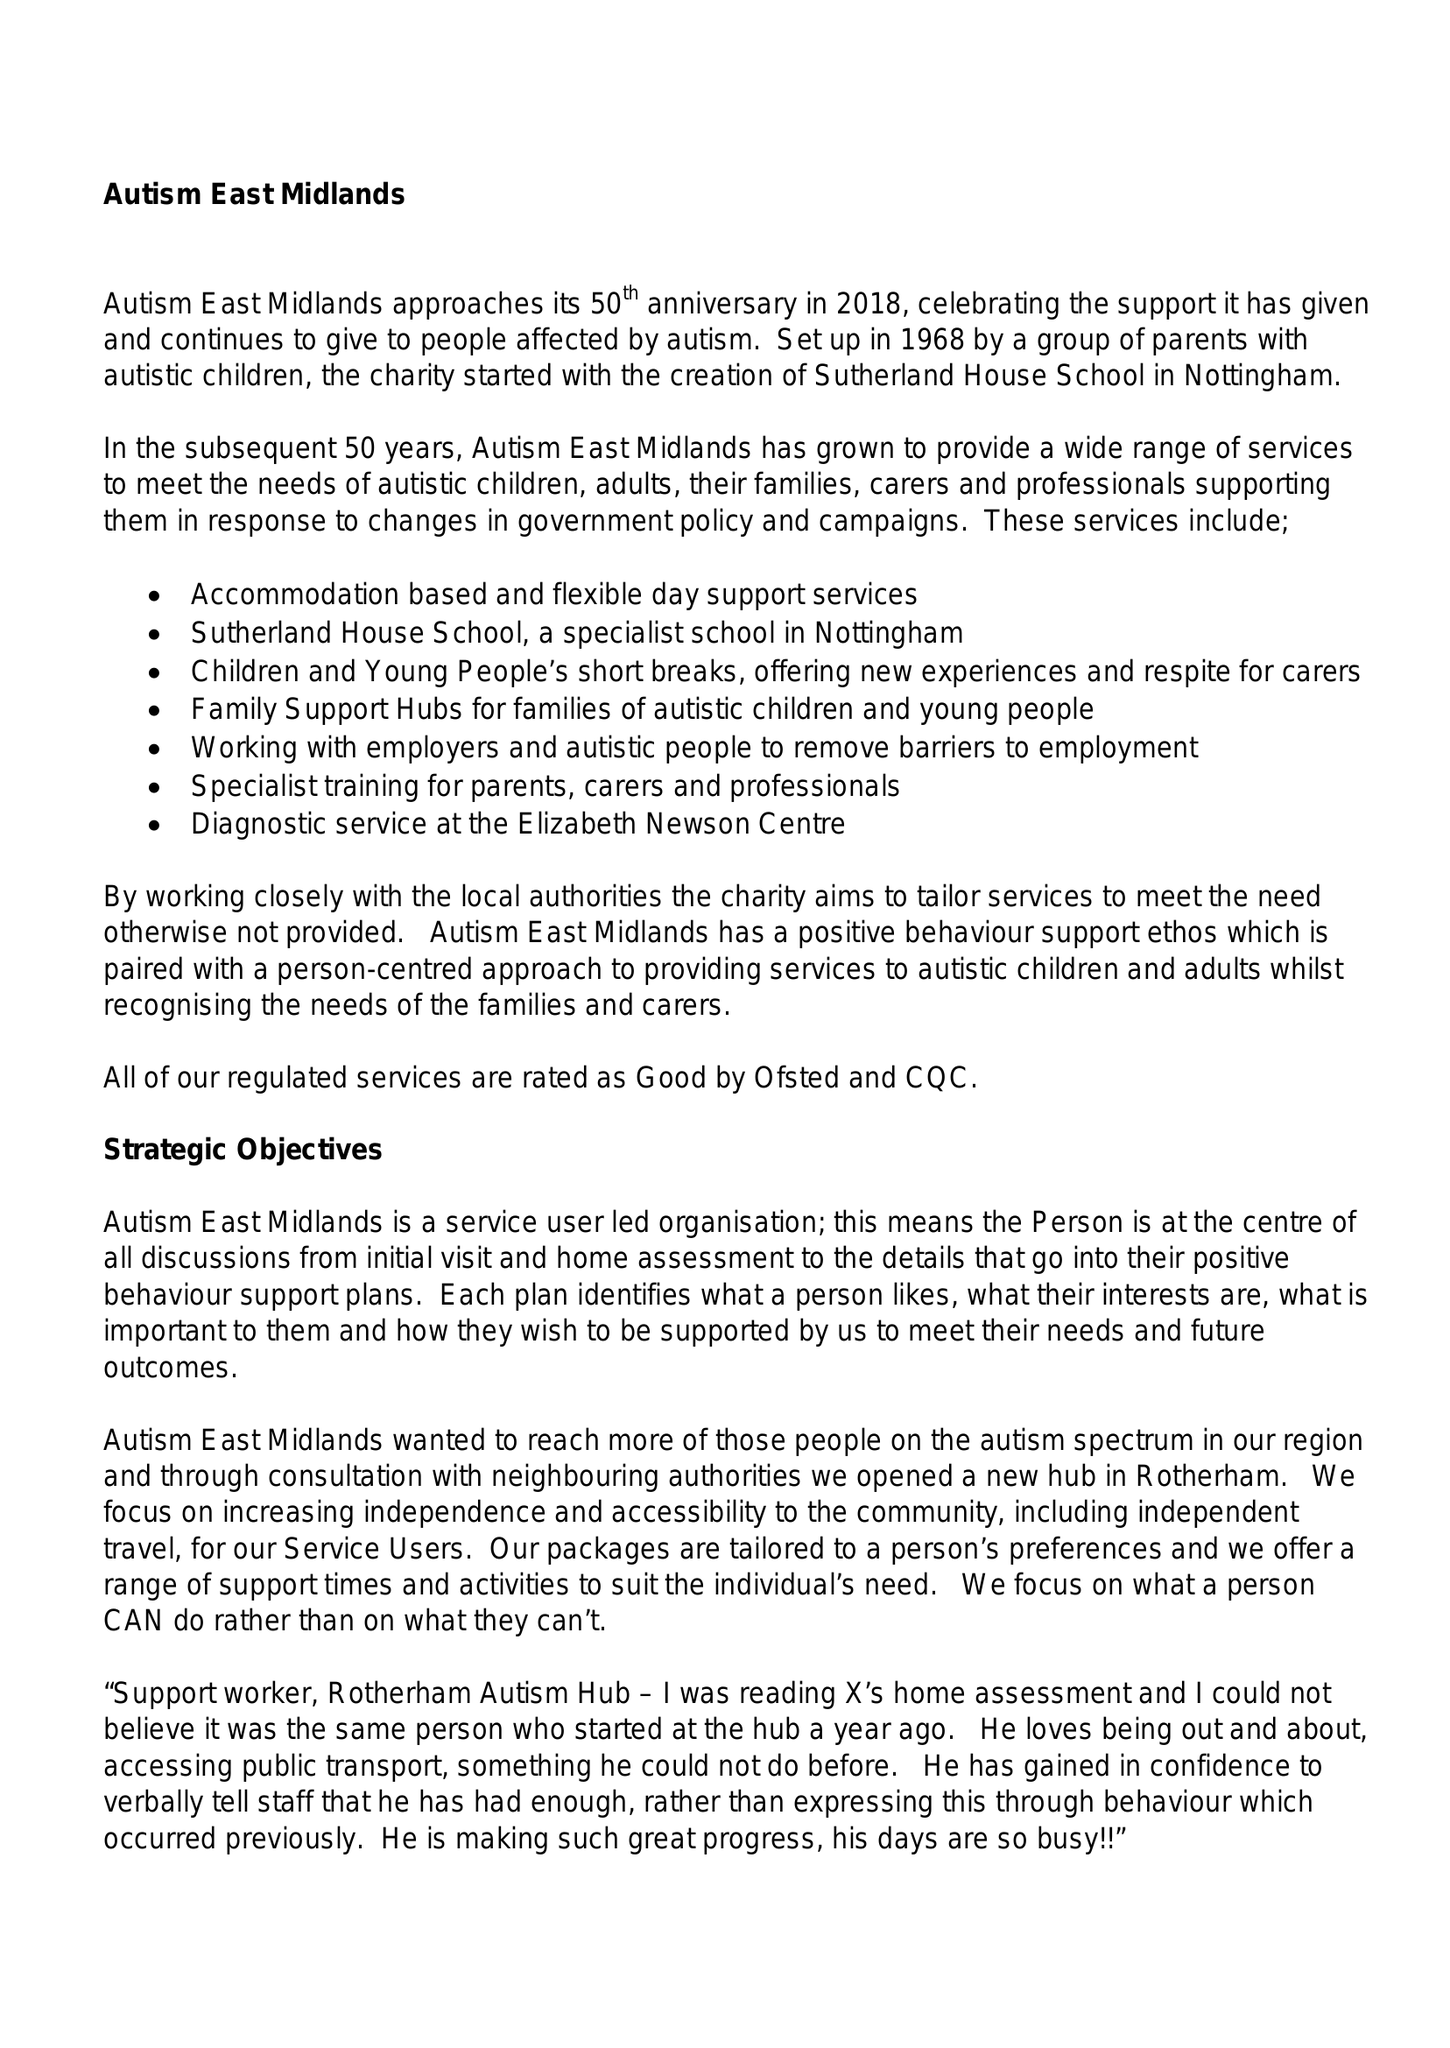What is the value for the charity_number?
Answer the question using a single word or phrase. 517954 